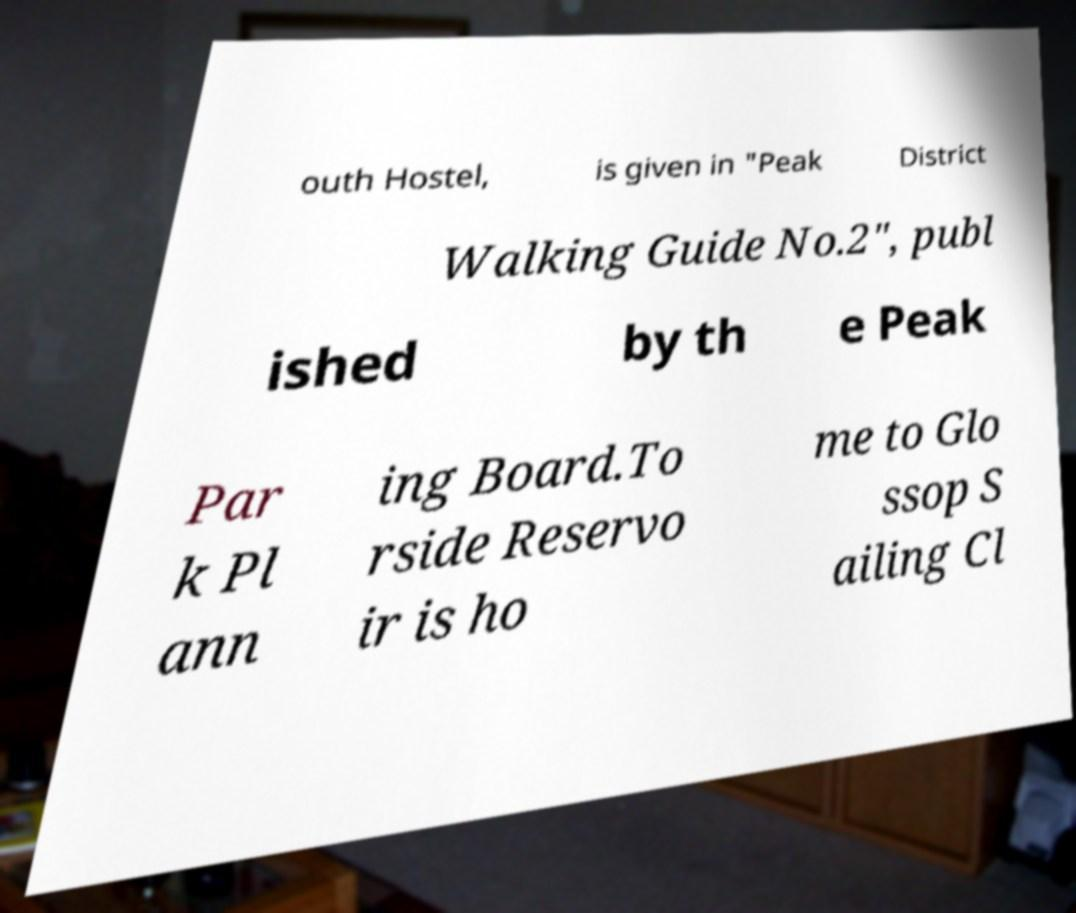Could you assist in decoding the text presented in this image and type it out clearly? outh Hostel, is given in "Peak District Walking Guide No.2", publ ished by th e Peak Par k Pl ann ing Board.To rside Reservo ir is ho me to Glo ssop S ailing Cl 